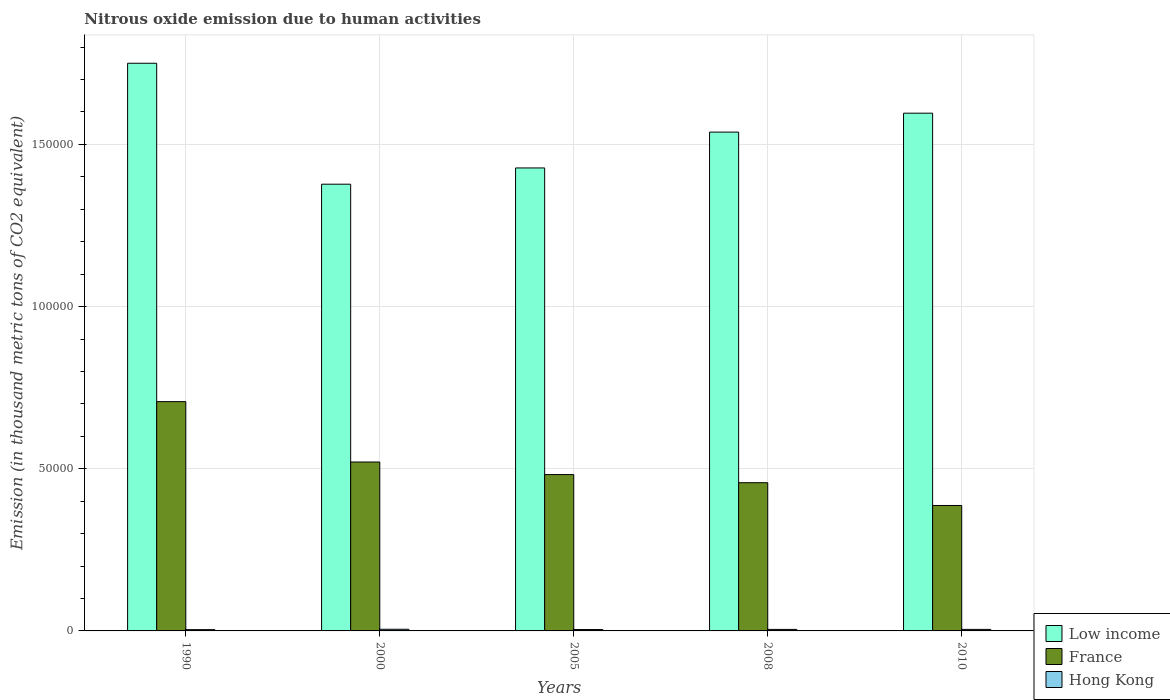Are the number of bars per tick equal to the number of legend labels?
Make the answer very short. Yes. Are the number of bars on each tick of the X-axis equal?
Keep it short and to the point. Yes. How many bars are there on the 4th tick from the left?
Give a very brief answer. 3. What is the label of the 3rd group of bars from the left?
Offer a very short reply. 2005. What is the amount of nitrous oxide emitted in Hong Kong in 2000?
Offer a very short reply. 513.2. Across all years, what is the maximum amount of nitrous oxide emitted in Hong Kong?
Ensure brevity in your answer.  513.2. Across all years, what is the minimum amount of nitrous oxide emitted in France?
Keep it short and to the point. 3.87e+04. What is the total amount of nitrous oxide emitted in Hong Kong in the graph?
Give a very brief answer. 2268.2. What is the difference between the amount of nitrous oxide emitted in France in 2005 and that in 2010?
Your answer should be very brief. 9531.2. What is the difference between the amount of nitrous oxide emitted in Low income in 2000 and the amount of nitrous oxide emitted in Hong Kong in 2008?
Your answer should be very brief. 1.37e+05. What is the average amount of nitrous oxide emitted in Hong Kong per year?
Provide a succinct answer. 453.64. In the year 2000, what is the difference between the amount of nitrous oxide emitted in France and amount of nitrous oxide emitted in Hong Kong?
Keep it short and to the point. 5.16e+04. In how many years, is the amount of nitrous oxide emitted in France greater than 20000 thousand metric tons?
Ensure brevity in your answer.  5. What is the ratio of the amount of nitrous oxide emitted in Low income in 1990 to that in 2008?
Provide a succinct answer. 1.14. Is the amount of nitrous oxide emitted in France in 2005 less than that in 2008?
Ensure brevity in your answer.  No. What is the difference between the highest and the second highest amount of nitrous oxide emitted in Low income?
Give a very brief answer. 1.54e+04. What is the difference between the highest and the lowest amount of nitrous oxide emitted in Low income?
Give a very brief answer. 3.73e+04. What does the 2nd bar from the left in 2008 represents?
Keep it short and to the point. France. What does the 1st bar from the right in 2010 represents?
Your answer should be very brief. Hong Kong. Are all the bars in the graph horizontal?
Provide a short and direct response. No. How many years are there in the graph?
Keep it short and to the point. 5. Are the values on the major ticks of Y-axis written in scientific E-notation?
Your response must be concise. No. Does the graph contain grids?
Provide a succinct answer. Yes. What is the title of the graph?
Make the answer very short. Nitrous oxide emission due to human activities. What is the label or title of the Y-axis?
Your answer should be very brief. Emission (in thousand metric tons of CO2 equivalent). What is the Emission (in thousand metric tons of CO2 equivalent) in Low income in 1990?
Give a very brief answer. 1.75e+05. What is the Emission (in thousand metric tons of CO2 equivalent) of France in 1990?
Provide a succinct answer. 7.07e+04. What is the Emission (in thousand metric tons of CO2 equivalent) of Hong Kong in 1990?
Your answer should be compact. 396.9. What is the Emission (in thousand metric tons of CO2 equivalent) of Low income in 2000?
Make the answer very short. 1.38e+05. What is the Emission (in thousand metric tons of CO2 equivalent) of France in 2000?
Your response must be concise. 5.21e+04. What is the Emission (in thousand metric tons of CO2 equivalent) of Hong Kong in 2000?
Offer a very short reply. 513.2. What is the Emission (in thousand metric tons of CO2 equivalent) of Low income in 2005?
Your answer should be compact. 1.43e+05. What is the Emission (in thousand metric tons of CO2 equivalent) of France in 2005?
Make the answer very short. 4.82e+04. What is the Emission (in thousand metric tons of CO2 equivalent) of Hong Kong in 2005?
Offer a very short reply. 428.2. What is the Emission (in thousand metric tons of CO2 equivalent) in Low income in 2008?
Your answer should be very brief. 1.54e+05. What is the Emission (in thousand metric tons of CO2 equivalent) of France in 2008?
Your response must be concise. 4.57e+04. What is the Emission (in thousand metric tons of CO2 equivalent) of Hong Kong in 2008?
Ensure brevity in your answer.  462.8. What is the Emission (in thousand metric tons of CO2 equivalent) in Low income in 2010?
Offer a very short reply. 1.60e+05. What is the Emission (in thousand metric tons of CO2 equivalent) in France in 2010?
Your answer should be compact. 3.87e+04. What is the Emission (in thousand metric tons of CO2 equivalent) of Hong Kong in 2010?
Offer a very short reply. 467.1. Across all years, what is the maximum Emission (in thousand metric tons of CO2 equivalent) of Low income?
Give a very brief answer. 1.75e+05. Across all years, what is the maximum Emission (in thousand metric tons of CO2 equivalent) of France?
Your response must be concise. 7.07e+04. Across all years, what is the maximum Emission (in thousand metric tons of CO2 equivalent) in Hong Kong?
Ensure brevity in your answer.  513.2. Across all years, what is the minimum Emission (in thousand metric tons of CO2 equivalent) of Low income?
Ensure brevity in your answer.  1.38e+05. Across all years, what is the minimum Emission (in thousand metric tons of CO2 equivalent) of France?
Make the answer very short. 3.87e+04. Across all years, what is the minimum Emission (in thousand metric tons of CO2 equivalent) of Hong Kong?
Make the answer very short. 396.9. What is the total Emission (in thousand metric tons of CO2 equivalent) of Low income in the graph?
Offer a terse response. 7.69e+05. What is the total Emission (in thousand metric tons of CO2 equivalent) in France in the graph?
Give a very brief answer. 2.55e+05. What is the total Emission (in thousand metric tons of CO2 equivalent) in Hong Kong in the graph?
Your response must be concise. 2268.2. What is the difference between the Emission (in thousand metric tons of CO2 equivalent) in Low income in 1990 and that in 2000?
Provide a succinct answer. 3.73e+04. What is the difference between the Emission (in thousand metric tons of CO2 equivalent) in France in 1990 and that in 2000?
Offer a terse response. 1.86e+04. What is the difference between the Emission (in thousand metric tons of CO2 equivalent) in Hong Kong in 1990 and that in 2000?
Offer a terse response. -116.3. What is the difference between the Emission (in thousand metric tons of CO2 equivalent) of Low income in 1990 and that in 2005?
Offer a terse response. 3.23e+04. What is the difference between the Emission (in thousand metric tons of CO2 equivalent) of France in 1990 and that in 2005?
Your response must be concise. 2.25e+04. What is the difference between the Emission (in thousand metric tons of CO2 equivalent) in Hong Kong in 1990 and that in 2005?
Provide a short and direct response. -31.3. What is the difference between the Emission (in thousand metric tons of CO2 equivalent) of Low income in 1990 and that in 2008?
Your answer should be very brief. 2.12e+04. What is the difference between the Emission (in thousand metric tons of CO2 equivalent) of France in 1990 and that in 2008?
Offer a terse response. 2.50e+04. What is the difference between the Emission (in thousand metric tons of CO2 equivalent) in Hong Kong in 1990 and that in 2008?
Give a very brief answer. -65.9. What is the difference between the Emission (in thousand metric tons of CO2 equivalent) of Low income in 1990 and that in 2010?
Make the answer very short. 1.54e+04. What is the difference between the Emission (in thousand metric tons of CO2 equivalent) of France in 1990 and that in 2010?
Offer a very short reply. 3.20e+04. What is the difference between the Emission (in thousand metric tons of CO2 equivalent) of Hong Kong in 1990 and that in 2010?
Keep it short and to the point. -70.2. What is the difference between the Emission (in thousand metric tons of CO2 equivalent) in Low income in 2000 and that in 2005?
Ensure brevity in your answer.  -5007.3. What is the difference between the Emission (in thousand metric tons of CO2 equivalent) of France in 2000 and that in 2005?
Offer a terse response. 3875.3. What is the difference between the Emission (in thousand metric tons of CO2 equivalent) of Hong Kong in 2000 and that in 2005?
Provide a succinct answer. 85. What is the difference between the Emission (in thousand metric tons of CO2 equivalent) of Low income in 2000 and that in 2008?
Give a very brief answer. -1.61e+04. What is the difference between the Emission (in thousand metric tons of CO2 equivalent) of France in 2000 and that in 2008?
Your answer should be very brief. 6378.7. What is the difference between the Emission (in thousand metric tons of CO2 equivalent) in Hong Kong in 2000 and that in 2008?
Your answer should be very brief. 50.4. What is the difference between the Emission (in thousand metric tons of CO2 equivalent) in Low income in 2000 and that in 2010?
Your answer should be very brief. -2.19e+04. What is the difference between the Emission (in thousand metric tons of CO2 equivalent) in France in 2000 and that in 2010?
Your answer should be very brief. 1.34e+04. What is the difference between the Emission (in thousand metric tons of CO2 equivalent) of Hong Kong in 2000 and that in 2010?
Your response must be concise. 46.1. What is the difference between the Emission (in thousand metric tons of CO2 equivalent) in Low income in 2005 and that in 2008?
Your answer should be compact. -1.11e+04. What is the difference between the Emission (in thousand metric tons of CO2 equivalent) in France in 2005 and that in 2008?
Offer a terse response. 2503.4. What is the difference between the Emission (in thousand metric tons of CO2 equivalent) of Hong Kong in 2005 and that in 2008?
Keep it short and to the point. -34.6. What is the difference between the Emission (in thousand metric tons of CO2 equivalent) in Low income in 2005 and that in 2010?
Ensure brevity in your answer.  -1.69e+04. What is the difference between the Emission (in thousand metric tons of CO2 equivalent) in France in 2005 and that in 2010?
Give a very brief answer. 9531.2. What is the difference between the Emission (in thousand metric tons of CO2 equivalent) in Hong Kong in 2005 and that in 2010?
Your answer should be very brief. -38.9. What is the difference between the Emission (in thousand metric tons of CO2 equivalent) of Low income in 2008 and that in 2010?
Your answer should be compact. -5836.5. What is the difference between the Emission (in thousand metric tons of CO2 equivalent) of France in 2008 and that in 2010?
Provide a succinct answer. 7027.8. What is the difference between the Emission (in thousand metric tons of CO2 equivalent) in Low income in 1990 and the Emission (in thousand metric tons of CO2 equivalent) in France in 2000?
Offer a terse response. 1.23e+05. What is the difference between the Emission (in thousand metric tons of CO2 equivalent) of Low income in 1990 and the Emission (in thousand metric tons of CO2 equivalent) of Hong Kong in 2000?
Your answer should be very brief. 1.74e+05. What is the difference between the Emission (in thousand metric tons of CO2 equivalent) in France in 1990 and the Emission (in thousand metric tons of CO2 equivalent) in Hong Kong in 2000?
Make the answer very short. 7.02e+04. What is the difference between the Emission (in thousand metric tons of CO2 equivalent) of Low income in 1990 and the Emission (in thousand metric tons of CO2 equivalent) of France in 2005?
Your answer should be very brief. 1.27e+05. What is the difference between the Emission (in thousand metric tons of CO2 equivalent) of Low income in 1990 and the Emission (in thousand metric tons of CO2 equivalent) of Hong Kong in 2005?
Make the answer very short. 1.75e+05. What is the difference between the Emission (in thousand metric tons of CO2 equivalent) in France in 1990 and the Emission (in thousand metric tons of CO2 equivalent) in Hong Kong in 2005?
Provide a short and direct response. 7.03e+04. What is the difference between the Emission (in thousand metric tons of CO2 equivalent) in Low income in 1990 and the Emission (in thousand metric tons of CO2 equivalent) in France in 2008?
Ensure brevity in your answer.  1.29e+05. What is the difference between the Emission (in thousand metric tons of CO2 equivalent) in Low income in 1990 and the Emission (in thousand metric tons of CO2 equivalent) in Hong Kong in 2008?
Make the answer very short. 1.75e+05. What is the difference between the Emission (in thousand metric tons of CO2 equivalent) in France in 1990 and the Emission (in thousand metric tons of CO2 equivalent) in Hong Kong in 2008?
Provide a succinct answer. 7.02e+04. What is the difference between the Emission (in thousand metric tons of CO2 equivalent) of Low income in 1990 and the Emission (in thousand metric tons of CO2 equivalent) of France in 2010?
Provide a succinct answer. 1.36e+05. What is the difference between the Emission (in thousand metric tons of CO2 equivalent) of Low income in 1990 and the Emission (in thousand metric tons of CO2 equivalent) of Hong Kong in 2010?
Your answer should be very brief. 1.75e+05. What is the difference between the Emission (in thousand metric tons of CO2 equivalent) of France in 1990 and the Emission (in thousand metric tons of CO2 equivalent) of Hong Kong in 2010?
Make the answer very short. 7.02e+04. What is the difference between the Emission (in thousand metric tons of CO2 equivalent) in Low income in 2000 and the Emission (in thousand metric tons of CO2 equivalent) in France in 2005?
Give a very brief answer. 8.95e+04. What is the difference between the Emission (in thousand metric tons of CO2 equivalent) of Low income in 2000 and the Emission (in thousand metric tons of CO2 equivalent) of Hong Kong in 2005?
Keep it short and to the point. 1.37e+05. What is the difference between the Emission (in thousand metric tons of CO2 equivalent) in France in 2000 and the Emission (in thousand metric tons of CO2 equivalent) in Hong Kong in 2005?
Make the answer very short. 5.16e+04. What is the difference between the Emission (in thousand metric tons of CO2 equivalent) of Low income in 2000 and the Emission (in thousand metric tons of CO2 equivalent) of France in 2008?
Your answer should be compact. 9.20e+04. What is the difference between the Emission (in thousand metric tons of CO2 equivalent) in Low income in 2000 and the Emission (in thousand metric tons of CO2 equivalent) in Hong Kong in 2008?
Your answer should be compact. 1.37e+05. What is the difference between the Emission (in thousand metric tons of CO2 equivalent) in France in 2000 and the Emission (in thousand metric tons of CO2 equivalent) in Hong Kong in 2008?
Keep it short and to the point. 5.16e+04. What is the difference between the Emission (in thousand metric tons of CO2 equivalent) in Low income in 2000 and the Emission (in thousand metric tons of CO2 equivalent) in France in 2010?
Offer a terse response. 9.91e+04. What is the difference between the Emission (in thousand metric tons of CO2 equivalent) of Low income in 2000 and the Emission (in thousand metric tons of CO2 equivalent) of Hong Kong in 2010?
Make the answer very short. 1.37e+05. What is the difference between the Emission (in thousand metric tons of CO2 equivalent) of France in 2000 and the Emission (in thousand metric tons of CO2 equivalent) of Hong Kong in 2010?
Offer a terse response. 5.16e+04. What is the difference between the Emission (in thousand metric tons of CO2 equivalent) of Low income in 2005 and the Emission (in thousand metric tons of CO2 equivalent) of France in 2008?
Offer a very short reply. 9.70e+04. What is the difference between the Emission (in thousand metric tons of CO2 equivalent) of Low income in 2005 and the Emission (in thousand metric tons of CO2 equivalent) of Hong Kong in 2008?
Provide a succinct answer. 1.42e+05. What is the difference between the Emission (in thousand metric tons of CO2 equivalent) of France in 2005 and the Emission (in thousand metric tons of CO2 equivalent) of Hong Kong in 2008?
Offer a terse response. 4.77e+04. What is the difference between the Emission (in thousand metric tons of CO2 equivalent) in Low income in 2005 and the Emission (in thousand metric tons of CO2 equivalent) in France in 2010?
Offer a terse response. 1.04e+05. What is the difference between the Emission (in thousand metric tons of CO2 equivalent) of Low income in 2005 and the Emission (in thousand metric tons of CO2 equivalent) of Hong Kong in 2010?
Ensure brevity in your answer.  1.42e+05. What is the difference between the Emission (in thousand metric tons of CO2 equivalent) of France in 2005 and the Emission (in thousand metric tons of CO2 equivalent) of Hong Kong in 2010?
Your answer should be compact. 4.77e+04. What is the difference between the Emission (in thousand metric tons of CO2 equivalent) in Low income in 2008 and the Emission (in thousand metric tons of CO2 equivalent) in France in 2010?
Offer a terse response. 1.15e+05. What is the difference between the Emission (in thousand metric tons of CO2 equivalent) of Low income in 2008 and the Emission (in thousand metric tons of CO2 equivalent) of Hong Kong in 2010?
Provide a short and direct response. 1.53e+05. What is the difference between the Emission (in thousand metric tons of CO2 equivalent) of France in 2008 and the Emission (in thousand metric tons of CO2 equivalent) of Hong Kong in 2010?
Offer a very short reply. 4.52e+04. What is the average Emission (in thousand metric tons of CO2 equivalent) in Low income per year?
Your answer should be very brief. 1.54e+05. What is the average Emission (in thousand metric tons of CO2 equivalent) of France per year?
Your answer should be very brief. 5.11e+04. What is the average Emission (in thousand metric tons of CO2 equivalent) in Hong Kong per year?
Provide a short and direct response. 453.64. In the year 1990, what is the difference between the Emission (in thousand metric tons of CO2 equivalent) in Low income and Emission (in thousand metric tons of CO2 equivalent) in France?
Make the answer very short. 1.04e+05. In the year 1990, what is the difference between the Emission (in thousand metric tons of CO2 equivalent) in Low income and Emission (in thousand metric tons of CO2 equivalent) in Hong Kong?
Ensure brevity in your answer.  1.75e+05. In the year 1990, what is the difference between the Emission (in thousand metric tons of CO2 equivalent) in France and Emission (in thousand metric tons of CO2 equivalent) in Hong Kong?
Your answer should be very brief. 7.03e+04. In the year 2000, what is the difference between the Emission (in thousand metric tons of CO2 equivalent) in Low income and Emission (in thousand metric tons of CO2 equivalent) in France?
Your response must be concise. 8.57e+04. In the year 2000, what is the difference between the Emission (in thousand metric tons of CO2 equivalent) in Low income and Emission (in thousand metric tons of CO2 equivalent) in Hong Kong?
Your answer should be compact. 1.37e+05. In the year 2000, what is the difference between the Emission (in thousand metric tons of CO2 equivalent) in France and Emission (in thousand metric tons of CO2 equivalent) in Hong Kong?
Offer a very short reply. 5.16e+04. In the year 2005, what is the difference between the Emission (in thousand metric tons of CO2 equivalent) in Low income and Emission (in thousand metric tons of CO2 equivalent) in France?
Offer a very short reply. 9.45e+04. In the year 2005, what is the difference between the Emission (in thousand metric tons of CO2 equivalent) of Low income and Emission (in thousand metric tons of CO2 equivalent) of Hong Kong?
Offer a very short reply. 1.42e+05. In the year 2005, what is the difference between the Emission (in thousand metric tons of CO2 equivalent) in France and Emission (in thousand metric tons of CO2 equivalent) in Hong Kong?
Provide a succinct answer. 4.78e+04. In the year 2008, what is the difference between the Emission (in thousand metric tons of CO2 equivalent) in Low income and Emission (in thousand metric tons of CO2 equivalent) in France?
Offer a very short reply. 1.08e+05. In the year 2008, what is the difference between the Emission (in thousand metric tons of CO2 equivalent) in Low income and Emission (in thousand metric tons of CO2 equivalent) in Hong Kong?
Offer a very short reply. 1.53e+05. In the year 2008, what is the difference between the Emission (in thousand metric tons of CO2 equivalent) in France and Emission (in thousand metric tons of CO2 equivalent) in Hong Kong?
Make the answer very short. 4.52e+04. In the year 2010, what is the difference between the Emission (in thousand metric tons of CO2 equivalent) in Low income and Emission (in thousand metric tons of CO2 equivalent) in France?
Offer a very short reply. 1.21e+05. In the year 2010, what is the difference between the Emission (in thousand metric tons of CO2 equivalent) of Low income and Emission (in thousand metric tons of CO2 equivalent) of Hong Kong?
Make the answer very short. 1.59e+05. In the year 2010, what is the difference between the Emission (in thousand metric tons of CO2 equivalent) of France and Emission (in thousand metric tons of CO2 equivalent) of Hong Kong?
Provide a succinct answer. 3.82e+04. What is the ratio of the Emission (in thousand metric tons of CO2 equivalent) in Low income in 1990 to that in 2000?
Provide a short and direct response. 1.27. What is the ratio of the Emission (in thousand metric tons of CO2 equivalent) of France in 1990 to that in 2000?
Your response must be concise. 1.36. What is the ratio of the Emission (in thousand metric tons of CO2 equivalent) in Hong Kong in 1990 to that in 2000?
Keep it short and to the point. 0.77. What is the ratio of the Emission (in thousand metric tons of CO2 equivalent) of Low income in 1990 to that in 2005?
Your answer should be compact. 1.23. What is the ratio of the Emission (in thousand metric tons of CO2 equivalent) of France in 1990 to that in 2005?
Offer a terse response. 1.47. What is the ratio of the Emission (in thousand metric tons of CO2 equivalent) of Hong Kong in 1990 to that in 2005?
Offer a terse response. 0.93. What is the ratio of the Emission (in thousand metric tons of CO2 equivalent) in Low income in 1990 to that in 2008?
Provide a succinct answer. 1.14. What is the ratio of the Emission (in thousand metric tons of CO2 equivalent) in France in 1990 to that in 2008?
Ensure brevity in your answer.  1.55. What is the ratio of the Emission (in thousand metric tons of CO2 equivalent) in Hong Kong in 1990 to that in 2008?
Give a very brief answer. 0.86. What is the ratio of the Emission (in thousand metric tons of CO2 equivalent) of Low income in 1990 to that in 2010?
Your answer should be very brief. 1.1. What is the ratio of the Emission (in thousand metric tons of CO2 equivalent) in France in 1990 to that in 2010?
Your answer should be compact. 1.83. What is the ratio of the Emission (in thousand metric tons of CO2 equivalent) of Hong Kong in 1990 to that in 2010?
Give a very brief answer. 0.85. What is the ratio of the Emission (in thousand metric tons of CO2 equivalent) of Low income in 2000 to that in 2005?
Provide a succinct answer. 0.96. What is the ratio of the Emission (in thousand metric tons of CO2 equivalent) of France in 2000 to that in 2005?
Your answer should be compact. 1.08. What is the ratio of the Emission (in thousand metric tons of CO2 equivalent) of Hong Kong in 2000 to that in 2005?
Your answer should be compact. 1.2. What is the ratio of the Emission (in thousand metric tons of CO2 equivalent) of Low income in 2000 to that in 2008?
Your answer should be compact. 0.9. What is the ratio of the Emission (in thousand metric tons of CO2 equivalent) in France in 2000 to that in 2008?
Your answer should be compact. 1.14. What is the ratio of the Emission (in thousand metric tons of CO2 equivalent) in Hong Kong in 2000 to that in 2008?
Provide a short and direct response. 1.11. What is the ratio of the Emission (in thousand metric tons of CO2 equivalent) of Low income in 2000 to that in 2010?
Offer a terse response. 0.86. What is the ratio of the Emission (in thousand metric tons of CO2 equivalent) in France in 2000 to that in 2010?
Your answer should be compact. 1.35. What is the ratio of the Emission (in thousand metric tons of CO2 equivalent) in Hong Kong in 2000 to that in 2010?
Provide a succinct answer. 1.1. What is the ratio of the Emission (in thousand metric tons of CO2 equivalent) of Low income in 2005 to that in 2008?
Offer a very short reply. 0.93. What is the ratio of the Emission (in thousand metric tons of CO2 equivalent) in France in 2005 to that in 2008?
Offer a very short reply. 1.05. What is the ratio of the Emission (in thousand metric tons of CO2 equivalent) of Hong Kong in 2005 to that in 2008?
Your answer should be compact. 0.93. What is the ratio of the Emission (in thousand metric tons of CO2 equivalent) of Low income in 2005 to that in 2010?
Your answer should be very brief. 0.89. What is the ratio of the Emission (in thousand metric tons of CO2 equivalent) in France in 2005 to that in 2010?
Your answer should be very brief. 1.25. What is the ratio of the Emission (in thousand metric tons of CO2 equivalent) in Hong Kong in 2005 to that in 2010?
Your answer should be compact. 0.92. What is the ratio of the Emission (in thousand metric tons of CO2 equivalent) of Low income in 2008 to that in 2010?
Keep it short and to the point. 0.96. What is the ratio of the Emission (in thousand metric tons of CO2 equivalent) of France in 2008 to that in 2010?
Provide a short and direct response. 1.18. What is the ratio of the Emission (in thousand metric tons of CO2 equivalent) of Hong Kong in 2008 to that in 2010?
Keep it short and to the point. 0.99. What is the difference between the highest and the second highest Emission (in thousand metric tons of CO2 equivalent) of Low income?
Give a very brief answer. 1.54e+04. What is the difference between the highest and the second highest Emission (in thousand metric tons of CO2 equivalent) in France?
Make the answer very short. 1.86e+04. What is the difference between the highest and the second highest Emission (in thousand metric tons of CO2 equivalent) in Hong Kong?
Make the answer very short. 46.1. What is the difference between the highest and the lowest Emission (in thousand metric tons of CO2 equivalent) in Low income?
Provide a succinct answer. 3.73e+04. What is the difference between the highest and the lowest Emission (in thousand metric tons of CO2 equivalent) of France?
Offer a terse response. 3.20e+04. What is the difference between the highest and the lowest Emission (in thousand metric tons of CO2 equivalent) in Hong Kong?
Provide a succinct answer. 116.3. 